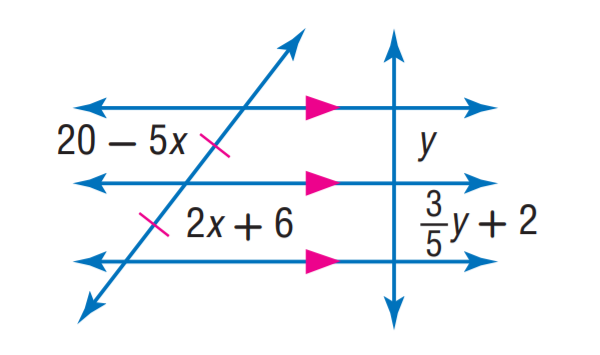Answer the mathemtical geometry problem and directly provide the correct option letter.
Question: Find x.
Choices: A: 2 B: 3 C: 4 D: 5 A 